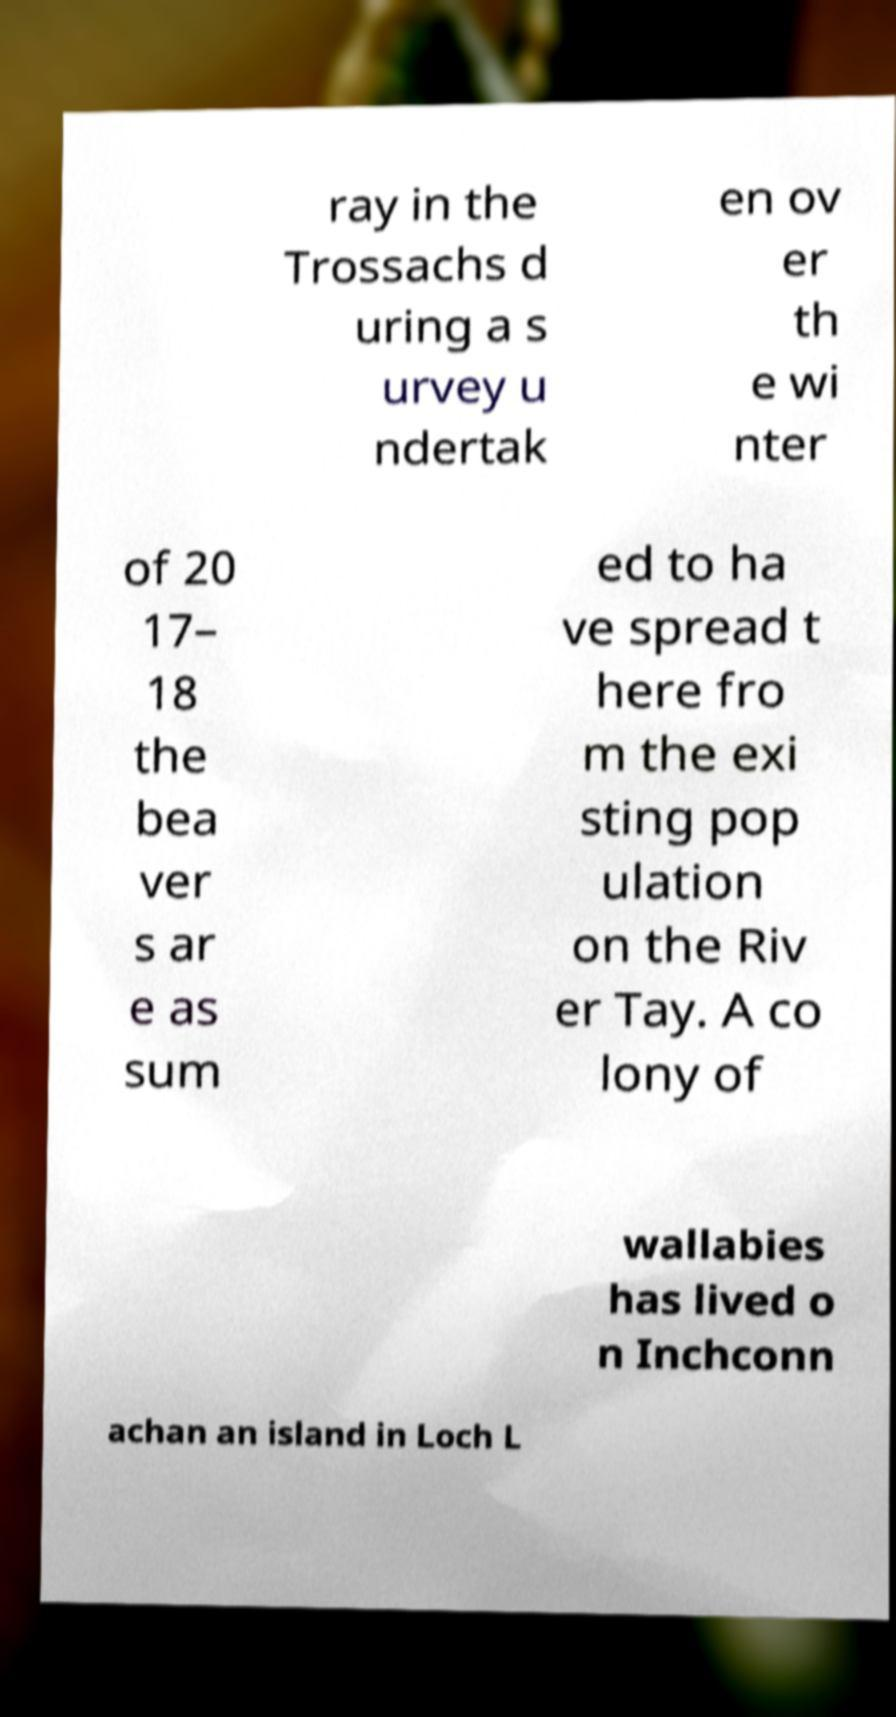Could you extract and type out the text from this image? ray in the Trossachs d uring a s urvey u ndertak en ov er th e wi nter of 20 17– 18 the bea ver s ar e as sum ed to ha ve spread t here fro m the exi sting pop ulation on the Riv er Tay. A co lony of wallabies has lived o n Inchconn achan an island in Loch L 